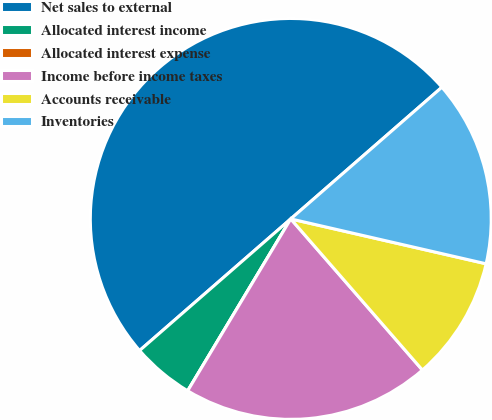Convert chart to OTSL. <chart><loc_0><loc_0><loc_500><loc_500><pie_chart><fcel>Net sales to external<fcel>Allocated interest income<fcel>Allocated interest expense<fcel>Income before income taxes<fcel>Accounts receivable<fcel>Inventories<nl><fcel>49.99%<fcel>5.0%<fcel>0.0%<fcel>20.0%<fcel>10.0%<fcel>15.0%<nl></chart> 